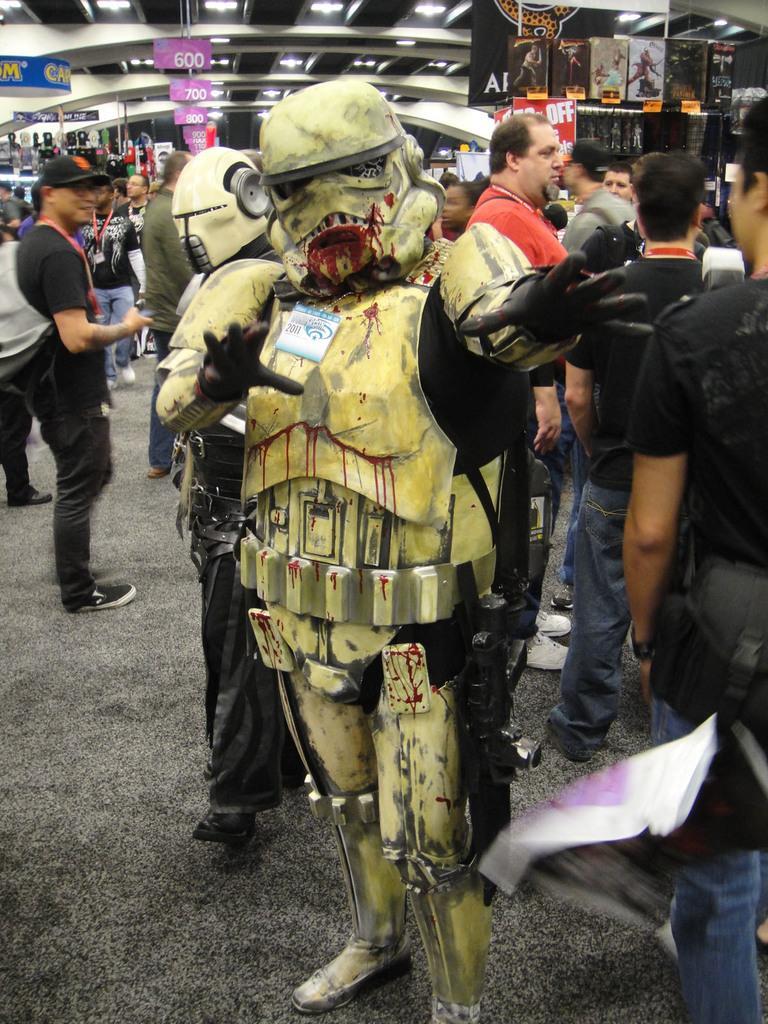Could you give a brief overview of what you see in this image? Here in this picture, in the middle we can see some people wearing cosplay and standing on the ground and behind them we can see other number of people standing and walking all over the floor and we can see some people are carrying bags with them and we can see number of banners and hoardings present all over there and we can also see lights present on the roof. 